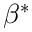<formula> <loc_0><loc_0><loc_500><loc_500>\beta ^ { * }</formula> 